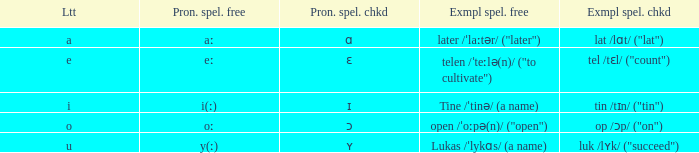What is Pronunciation Spelled Free, when Pronunciation Spelled Checked is "ɛ"? Eː. 